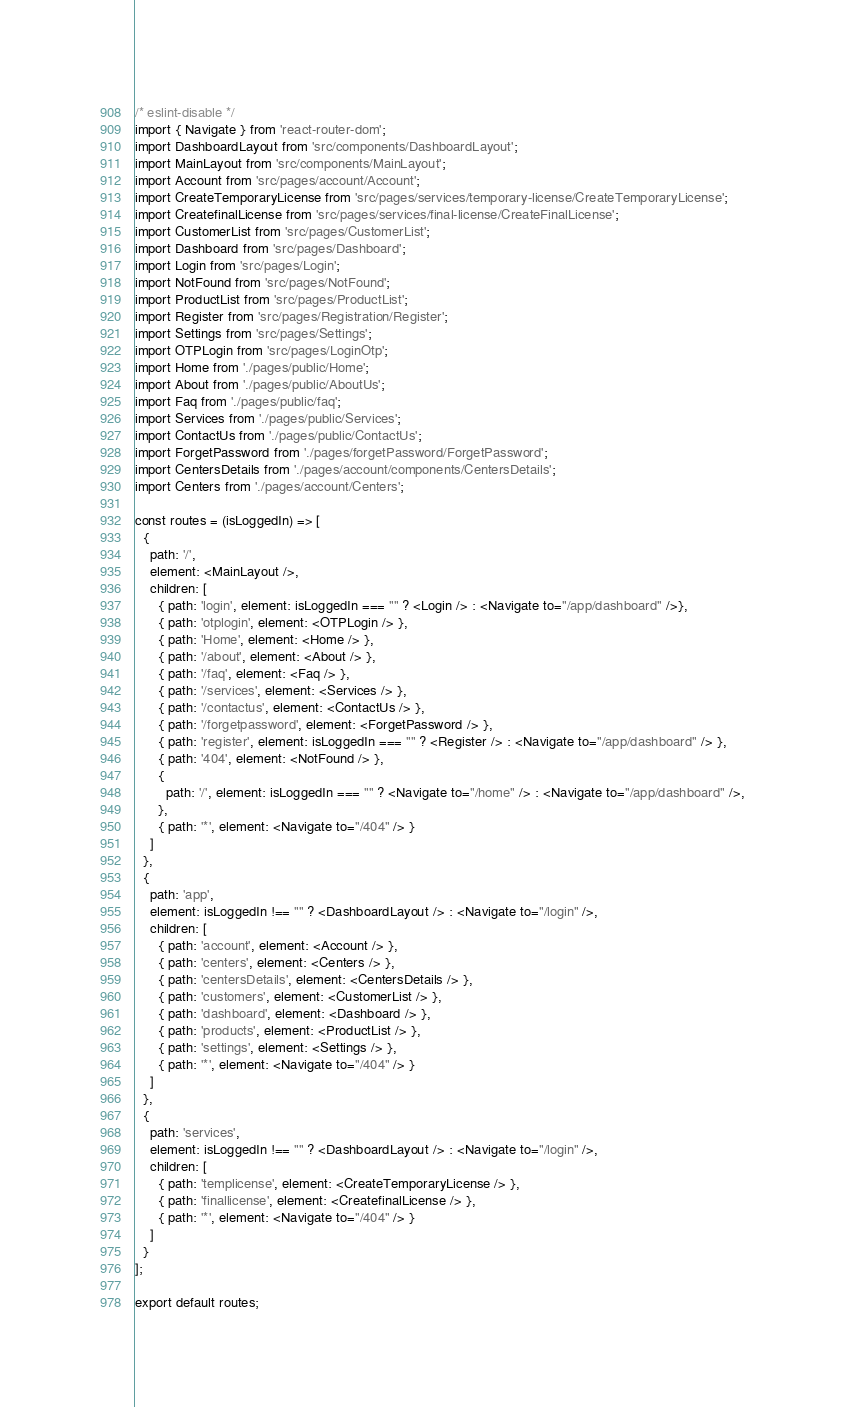Convert code to text. <code><loc_0><loc_0><loc_500><loc_500><_JavaScript_>/* eslint-disable */
import { Navigate } from 'react-router-dom';
import DashboardLayout from 'src/components/DashboardLayout';
import MainLayout from 'src/components/MainLayout';
import Account from 'src/pages/account/Account';
import CreateTemporaryLicense from 'src/pages/services/temporary-license/CreateTemporaryLicense';
import CreatefinalLicense from 'src/pages/services/final-license/CreateFinalLicense';
import CustomerList from 'src/pages/CustomerList';
import Dashboard from 'src/pages/Dashboard';
import Login from 'src/pages/Login';
import NotFound from 'src/pages/NotFound';
import ProductList from 'src/pages/ProductList';
import Register from 'src/pages/Registration/Register';
import Settings from 'src/pages/Settings';
import OTPLogin from 'src/pages/LoginOtp';
import Home from './pages/public/Home';
import About from './pages/public/AboutUs';
import Faq from './pages/public/faq';
import Services from './pages/public/Services';
import ContactUs from './pages/public/ContactUs';
import ForgetPassword from './pages/forgetPassword/ForgetPassword';
import CentersDetails from './pages/account/components/CentersDetails';
import Centers from './pages/account/Centers';

const routes = (isLoggedIn) => [
  {
    path: '/',
    element: <MainLayout />,
    children: [
      { path: 'login', element: isLoggedIn === "" ? <Login /> : <Navigate to="/app/dashboard" />},
      { path: 'otplogin', element: <OTPLogin /> },
      { path: 'Home', element: <Home /> },
      { path: '/about', element: <About /> },
      { path: '/faq', element: <Faq /> },
      { path: '/services', element: <Services /> },
      { path: '/contactus', element: <ContactUs /> },
      { path: '/forgetpassword', element: <ForgetPassword /> },
      { path: 'register', element: isLoggedIn === "" ? <Register /> : <Navigate to="/app/dashboard" /> },
      { path: '404', element: <NotFound /> },
      {
        path: '/', element: isLoggedIn === "" ? <Navigate to="/home" /> : <Navigate to="/app/dashboard" />,
      },
      { path: '*', element: <Navigate to="/404" /> }
    ]
  },
  {
    path: 'app',
    element: isLoggedIn !== "" ? <DashboardLayout /> : <Navigate to="/login" />,
    children: [
      { path: 'account', element: <Account /> },
      { path: 'centers', element: <Centers /> },
      { path: 'centersDetails', element: <CentersDetails /> },
      { path: 'customers', element: <CustomerList /> },
      { path: 'dashboard', element: <Dashboard /> },
      { path: 'products', element: <ProductList /> },
      { path: 'settings', element: <Settings /> },
      { path: '*', element: <Navigate to="/404" /> }
    ]
  },
  {
    path: 'services',
    element: isLoggedIn !== "" ? <DashboardLayout /> : <Navigate to="/login" />,
    children: [
      { path: 'templicense', element: <CreateTemporaryLicense /> },
      { path: 'finallicense', element: <CreatefinalLicense /> },
      { path: '*', element: <Navigate to="/404" /> }
    ]
  }
];

export default routes;
</code> 